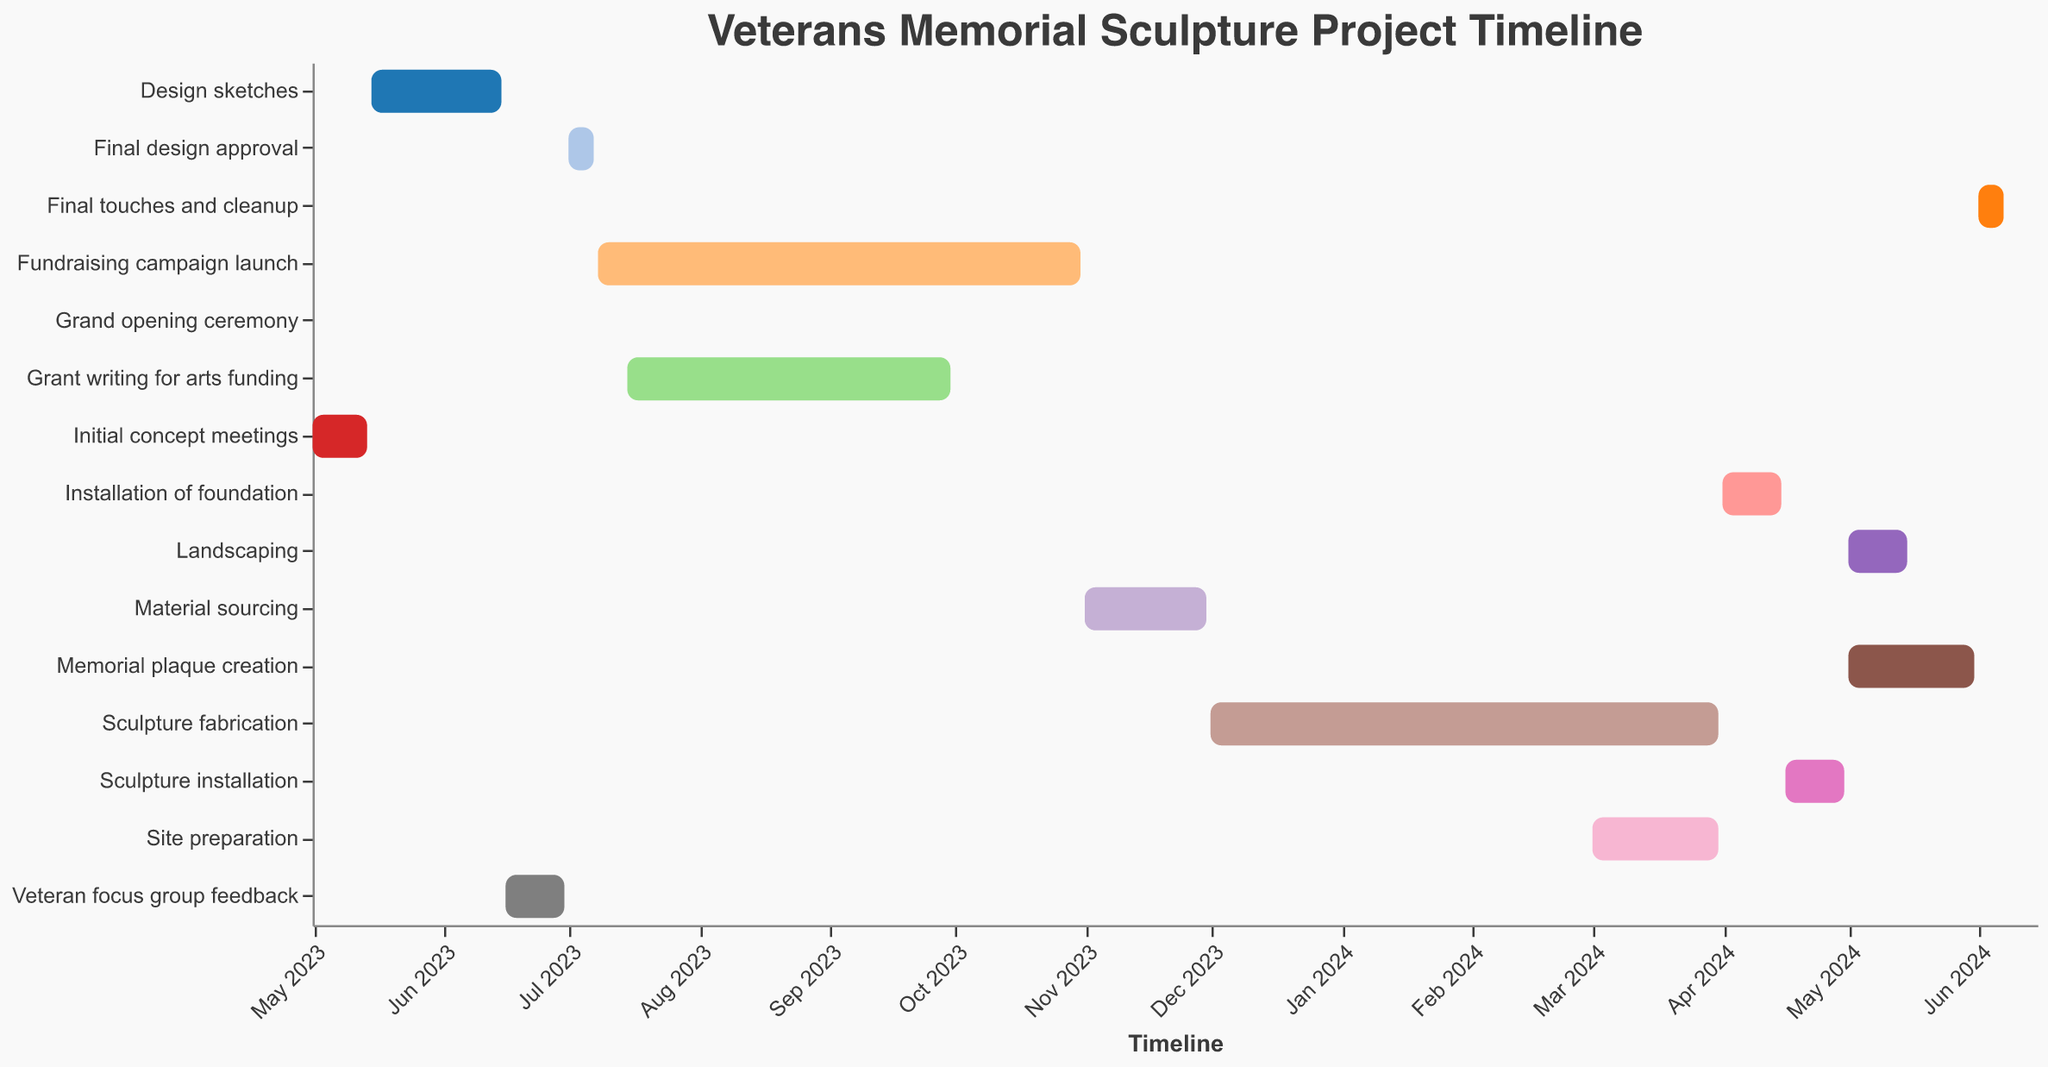What is the title of the chart? The title of the chart is positioned at the top center of the figure and is clearly labeled to describe what the Gantt Chart represents.
Answer: Veterans Memorial Sculpture Project Timeline How long did the "Design sketches" phase last? The "Design sketches" task starts on May 15, 2023, and ends on June 15, 2023. To find the duration, calculate the difference between the end date and the start date. There are 31 days in May with 14 days remaining after the 15th, plus the 15 days in June, which equals 31 days.
Answer: 31 days Which phase(s) overlap with the "Site preparation" phase? The "Site preparation" phase runs from March 1, 2024, to March 31, 2024. Checking the dates, the "Sculpture fabrication" phase (ending March 31, 2024) overlaps entirely with "Site preparation".
Answer: Sculpture fabrication What is the shortest task in the project? To determine the shortest task, identify the duration of each task and compare them. The "Final design approval" task, from July 1, 2023, to July 7, 2023, lasts 7 days and is the shortest.
Answer: Final design approval What tasks extend into May 2024? Tasks that include or extend into May 2024 are identified by their start and end dates. "Landscaping" (May 1 - May 15, 2024) and "Memorial plaque creation" (May 1 - May 31, 2024) both fall into May 2024.
Answer: Landscaping, Memorial plaque creation How many days in total is the "Fundraising campaign launch" phase? The "Fundraising campaign launch" starts on July 8, 2023, and ends on October 31, 2023. Counting the days in each month, it spans 24 days in July, 31 in August, 30 in September, and 31 in October, adding up to 116 days.
Answer: 116 days What's the total duration from the start of the "Initial concept meetings" to the "Grand opening ceremony"? The project spans from May 1, 2023 (the start of "Initial concept meetings") to June 15, 2024 (the "Grand opening ceremony"). To find the total duration, calculate the periods for each full year and partial month. May 1, 2023 - May 1, 2024 is one year, adding 44 more days from May 1 to June 15, making it 410 days (365 + 45).
Answer: 410 days Which tasks directly follow "Site preparation"? The tasks that start right after "Site preparation" ends on March 31, 2024, are "Installation of foundation" from April 1, 2024, to April 15, 2024.
Answer: Installation of foundation Are "Material sourcing" and "Grant writing for arts funding" phases overlapping? "Grant writing for arts funding" runs from July 15 to September 30, 2023, and "Material sourcing" runs from November 1 to November 30, 2023. Since there is no overlap in their date ranges, they do not overlap.
Answer: No When is the "Grand opening ceremony" scheduled? The "Grand opening ceremony" is a single-day event explicitly marked on June 15, 2024, in the Gantt Chart.
Answer: June 15, 2024 